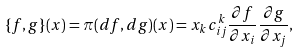Convert formula to latex. <formula><loc_0><loc_0><loc_500><loc_500>\{ f , g \} ( x ) = \pi ( d f , d g ) ( x ) = x _ { k } c _ { i j } ^ { k } \frac { \partial f } { \partial x _ { i } } \frac { \partial g } { \partial x _ { j } } ,</formula> 